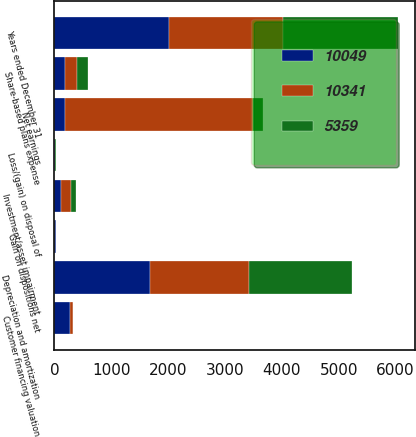<chart> <loc_0><loc_0><loc_500><loc_500><stacked_bar_chart><ecel><fcel>Years ended December 31<fcel>Net earnings<fcel>Share-based plans expense<fcel>Depreciation and amortization<fcel>Investment/asset impairment<fcel>Customer financing valuation<fcel>Loss/(gain) on disposal of<fcel>Gain on dispositions net<nl><fcel>5359<fcel>2012<fcel>180<fcel>193<fcel>1811<fcel>84<fcel>10<fcel>5<fcel>4<nl><fcel>10049<fcel>2011<fcel>180<fcel>186<fcel>1675<fcel>119<fcel>269<fcel>11<fcel>24<nl><fcel>10341<fcel>2010<fcel>3307<fcel>215<fcel>1746<fcel>174<fcel>51<fcel>6<fcel>6<nl></chart> 